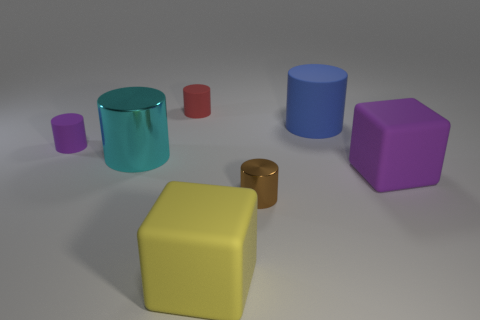Subtract 1 cylinders. How many cylinders are left? 4 Subtract all brown cylinders. How many cylinders are left? 4 Subtract all cyan cylinders. How many cylinders are left? 4 Subtract all green cylinders. Subtract all yellow spheres. How many cylinders are left? 5 Add 1 large blue objects. How many objects exist? 8 Subtract all cubes. How many objects are left? 5 Add 6 large green metal cubes. How many large green metal cubes exist? 6 Subtract 1 purple cylinders. How many objects are left? 6 Subtract all small cubes. Subtract all tiny purple matte cylinders. How many objects are left? 6 Add 4 large blocks. How many large blocks are left? 6 